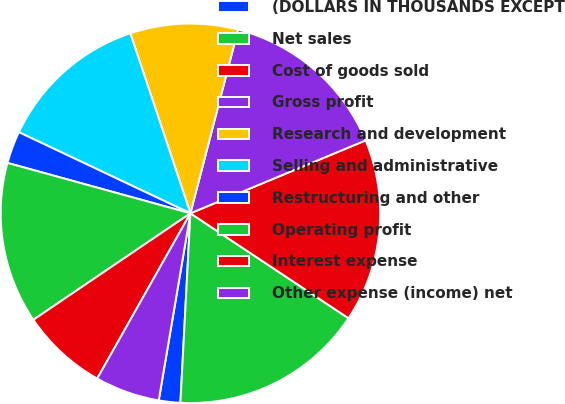Convert chart. <chart><loc_0><loc_0><loc_500><loc_500><pie_chart><fcel>(DOLLARS IN THOUSANDS EXCEPT<fcel>Net sales<fcel>Cost of goods sold<fcel>Gross profit<fcel>Research and development<fcel>Selling and administrative<fcel>Restructuring and other<fcel>Operating profit<fcel>Interest expense<fcel>Other expense (income) net<nl><fcel>1.83%<fcel>16.51%<fcel>15.6%<fcel>14.68%<fcel>9.17%<fcel>12.84%<fcel>2.75%<fcel>13.76%<fcel>7.34%<fcel>5.5%<nl></chart> 